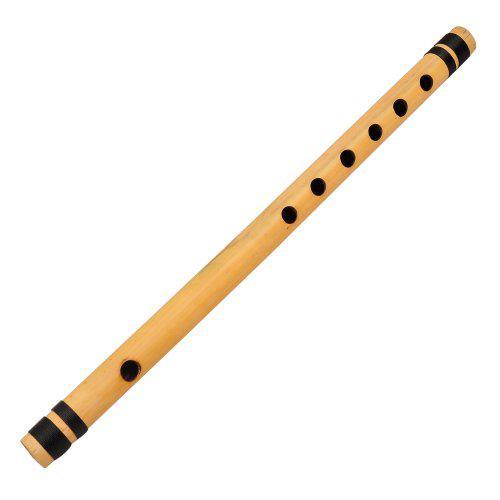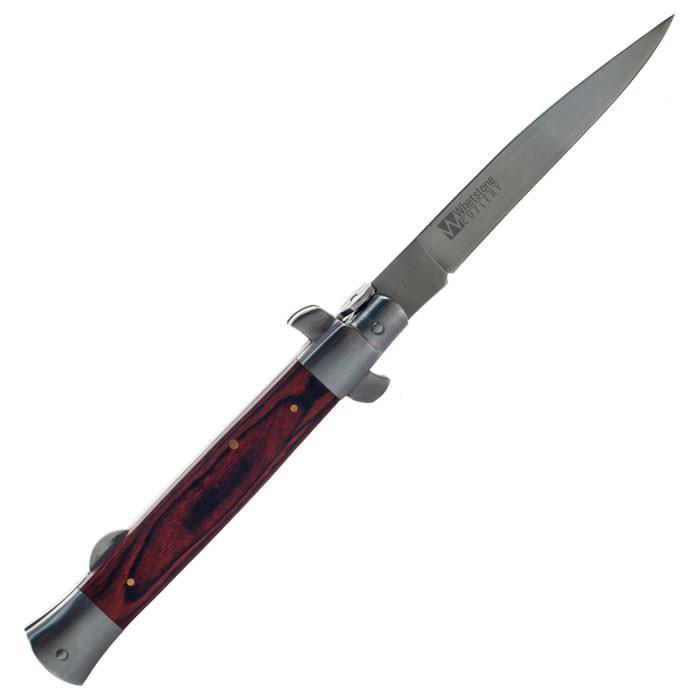The first image is the image on the left, the second image is the image on the right. Considering the images on both sides, is "One of the instruments is taken apart into two separate pieces." valid? Answer yes or no. No. The first image is the image on the left, the second image is the image on the right. For the images displayed, is the sentence "The instrument in the image on the right is broken apart into several pieces." factually correct? Answer yes or no. No. 